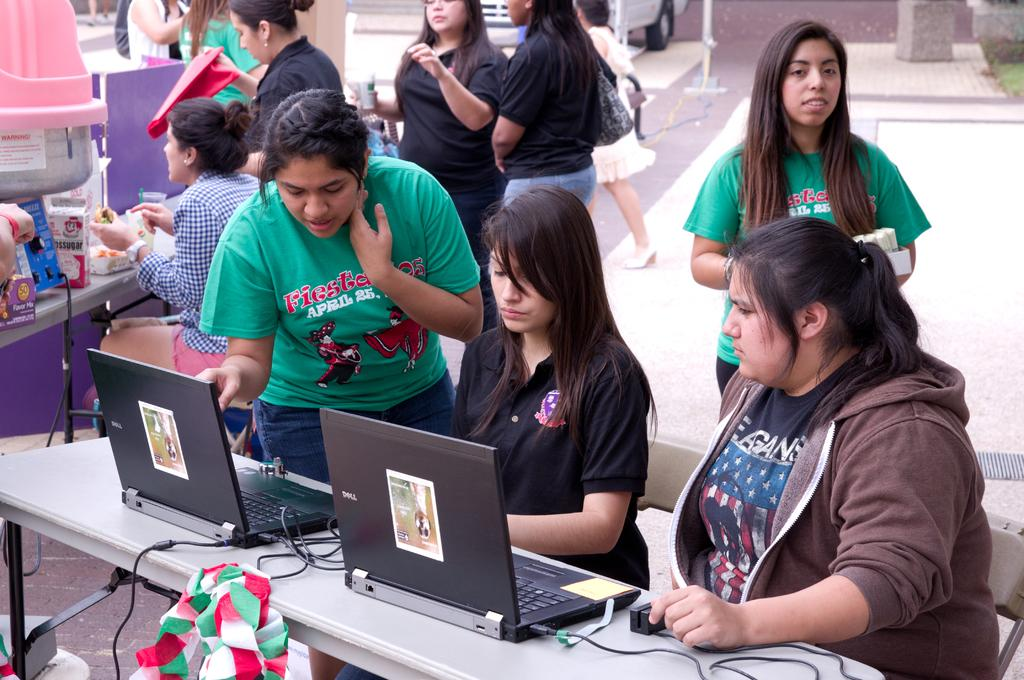<image>
Provide a brief description of the given image. A woman in a green shirt that says fiesta on it leans over a laptop. 